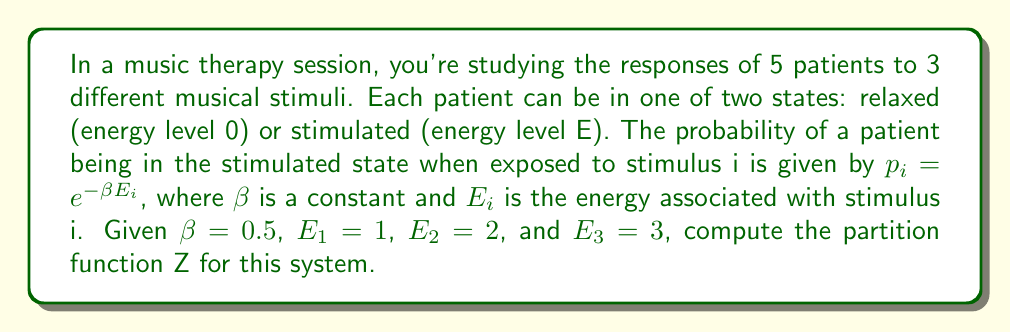Teach me how to tackle this problem. To solve this problem, we'll follow these steps:

1) The partition function Z for a system with multiple independent subsystems is the product of the partition functions of each subsystem. In this case, we have 5 independent patients, so:

   $$Z = (Z_1)^5$$

   where $Z_1$ is the partition function for a single patient.

2) For each patient, there are three possible stimuli, each with two possible states. The partition function for a single patient is:

   $$Z_1 = \sum_{i=1}^3 (1 + e^{-\beta E_i})$$

   where 1 represents the relaxed state (energy 0) and $e^{-\beta E_i}$ represents the stimulated state for stimulus i.

3) Let's calculate each term:

   For stimulus 1: $1 + e^{-0.5 \cdot 1} = 1 + e^{-0.5} \approx 1.6065$
   For stimulus 2: $1 + e^{-0.5 \cdot 2} = 1 + e^{-1} \approx 1.3679$
   For stimulus 3: $1 + e^{-0.5 \cdot 3} = 1 + e^{-1.5} \approx 1.2231$

4) Sum these terms:

   $$Z_1 = 1.6065 + 1.3679 + 1.2231 = 4.1975$$

5) Now, we can calculate the total partition function:

   $$Z = (4.1975)^5 \approx 1367.1$$
Answer: $Z \approx 1367.1$ 